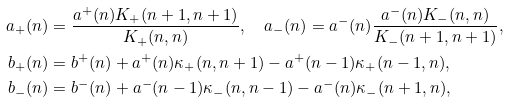<formula> <loc_0><loc_0><loc_500><loc_500>a _ { + } ( n ) & = \frac { a ^ { + } ( n ) K _ { + } ( n + 1 , n + 1 ) } { K _ { + } ( n , n ) } , \quad a _ { - } ( n ) = a ^ { - } ( n ) \frac { a ^ { - } ( n ) K _ { - } ( n , n ) } { K _ { - } ( n + 1 , n + 1 ) } , \\ b _ { + } ( n ) & = b ^ { + } ( n ) + a ^ { + } ( n ) \kappa _ { + } ( n , n + 1 ) - a ^ { + } ( n - 1 ) \kappa _ { + } ( n - 1 , n ) , \\ b _ { - } ( n ) & = b ^ { - } ( n ) + a ^ { - } ( n - 1 ) \kappa _ { - } ( n , n - 1 ) - a ^ { - } ( n ) \kappa _ { - } ( n + 1 , n ) ,</formula> 